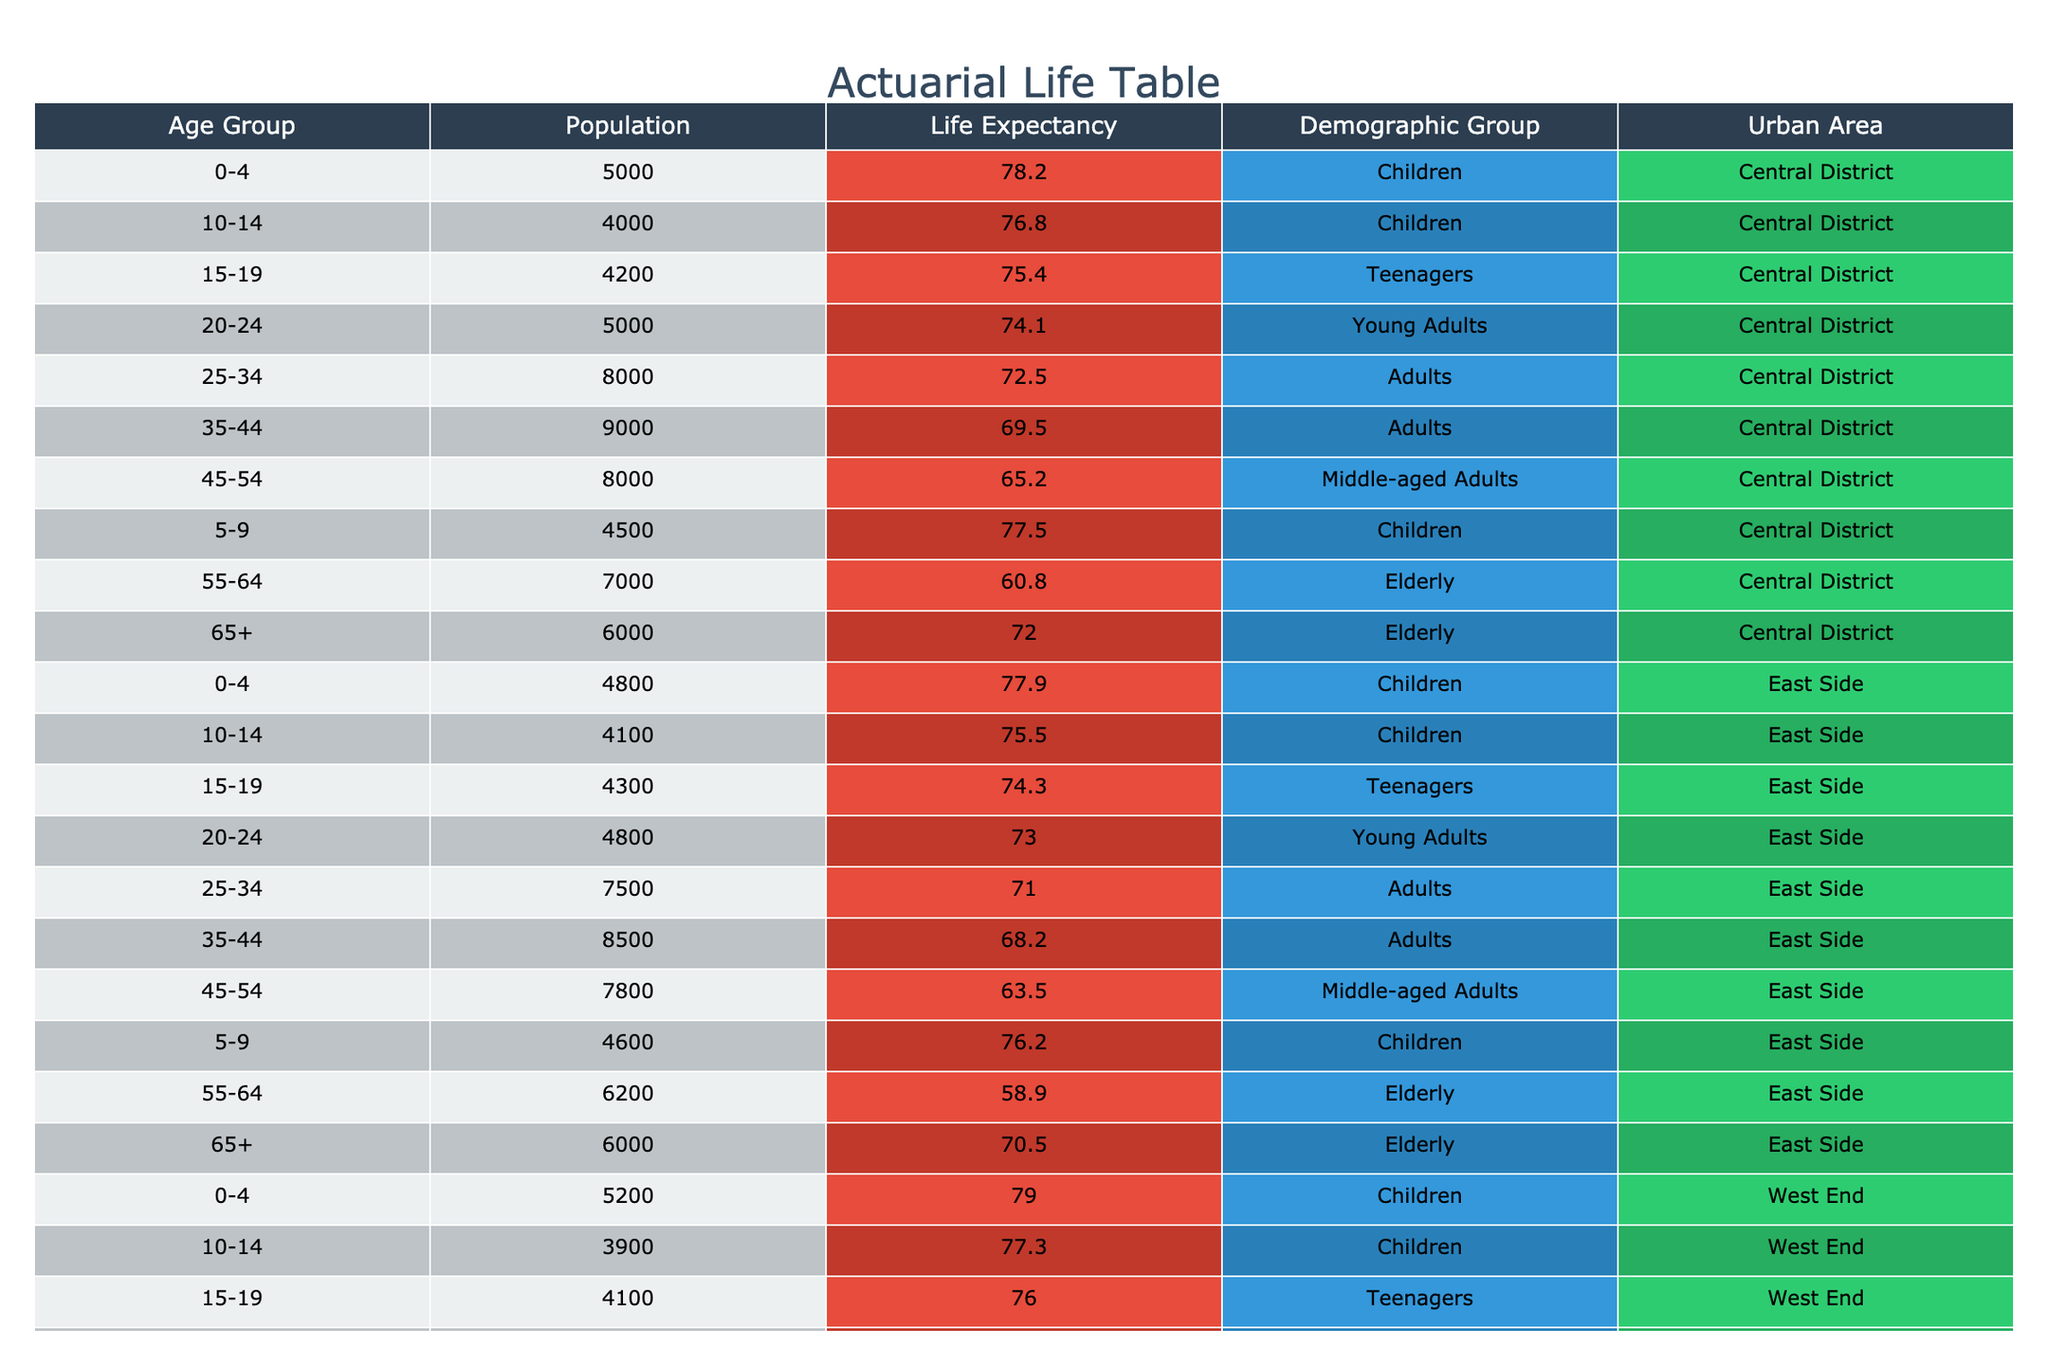What is the life expectancy of elderly individuals in the Central District? The table shows that for the elderly demographic group in the Central District, the life expectancy is recorded as 72.0 years.
Answer: 72.0 years What is the life expectancy of children in the East Side? According to the table, the life expectancy for children in the East Side is 77.9 years.
Answer: 77.9 years What is the average life expectancy of young adults across all urban areas? The life expectancies for young adults are 74.1 (Central District), 73.0 (East Side), and 74.7 (West End). To find the average, add these values: 74.1 + 73.0 + 74.7 = 221.8 and then divide by 3, resulting in an average life expectancy of approximately 73.93 years.
Answer: 73.93 years Are children in the West End expected to live longer than those in the East Side? The life expectancy of children in the West End is 79.0 years and in the East Side is 77.9 years. Since 79.0 is greater than 77.9, children in the West End are expected to live longer.
Answer: Yes What is the difference in life expectancy between middle-aged adults in the Central District and the East Side? The life expectancy for middle-aged adults in the Central District is 65.2 years, while in the East Side it is 63.5 years. The difference is calculated by subtracting: 65.2 - 63.5 = 1.7 years.
Answer: 1.7 years What is the life expectancy of teenagers in the West End? From the table, it can be observed that teenagers in the West End have a life expectancy of 76.0 years.
Answer: 76.0 years Which demographic group has the highest life expectancy in the East Side? In the East Side, the life expectancy values for each demographic group are as follows: Children 77.9, Teenagers 74.3, Young Adults 73.0, Adults 71.0, Middle-aged Adults 63.5, and Elderly 70.5. The highest of these values is 77.9 years for Children.
Answer: Children How does the life expectancy of elderly individuals in the West End compare to that in the Central District? The life expectancy for elderly individuals in the West End is 73.0 years, while in the Central District it is 72.0 years. Comparing these values shows that the West End has a higher life expectancy by 1 year.
Answer: 1 year difference, West End > Central District 